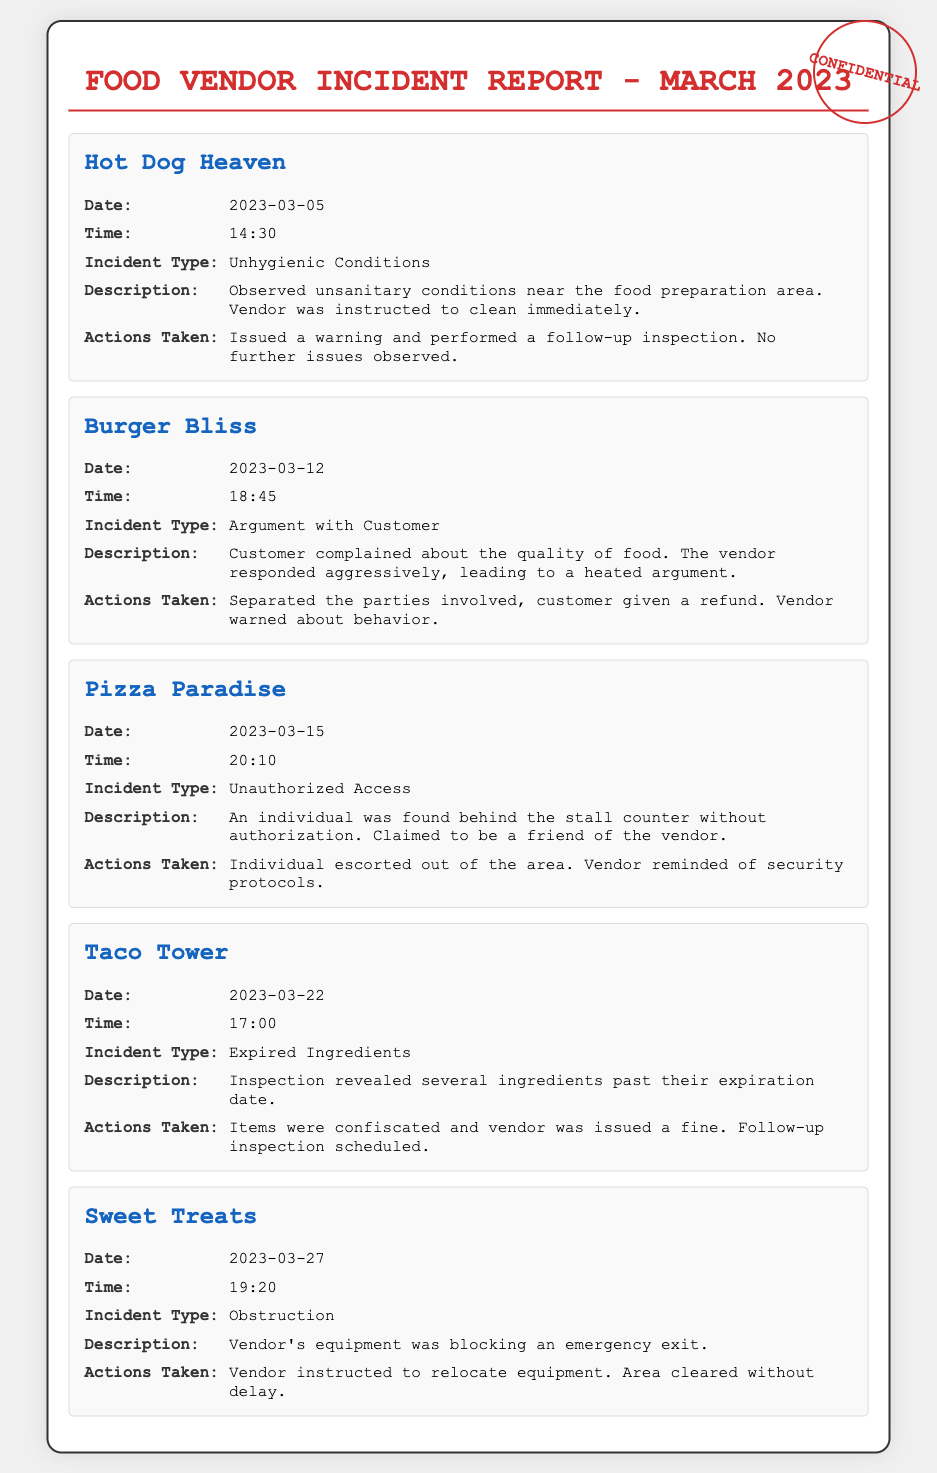what was the incident type for Hot Dog Heaven? The incident type for Hot Dog Heaven was observed on March 5, 2023, which was unhygienic conditions.
Answer: Unhygienic Conditions what action was taken after the incident at Burger Bliss? Following the argument incident at Burger Bliss on March 12, 2023, the vendor was warned about their behavior.
Answer: Vendor warned on what date did the incident involving expired ingredients occur? The incident involving expired ingredients took place on March 22, 2023.
Answer: 2023-03-22 how many incidents are documented in total? There are five documented incidents involving food vendors during March 2023.
Answer: Five what was the time of the incident at Sweet Treats? The Sweet Treats incident occurred at 19:20.
Answer: 19:20 what was the nature of the unauthorized access at Pizza Paradise? The unauthorized access at Pizza Paradise involved an individual found behind the stall counter.
Answer: Individual behind stall counter what was the consequence for Taco Tower for having expired ingredients? Taco Tower faced a fine for having expired ingredients.
Answer: Issued a fine which vendor's equipment obstructed an emergency exit? The vendor whose equipment obstructed an emergency exit was Sweet Treats.
Answer: Sweet Treats 